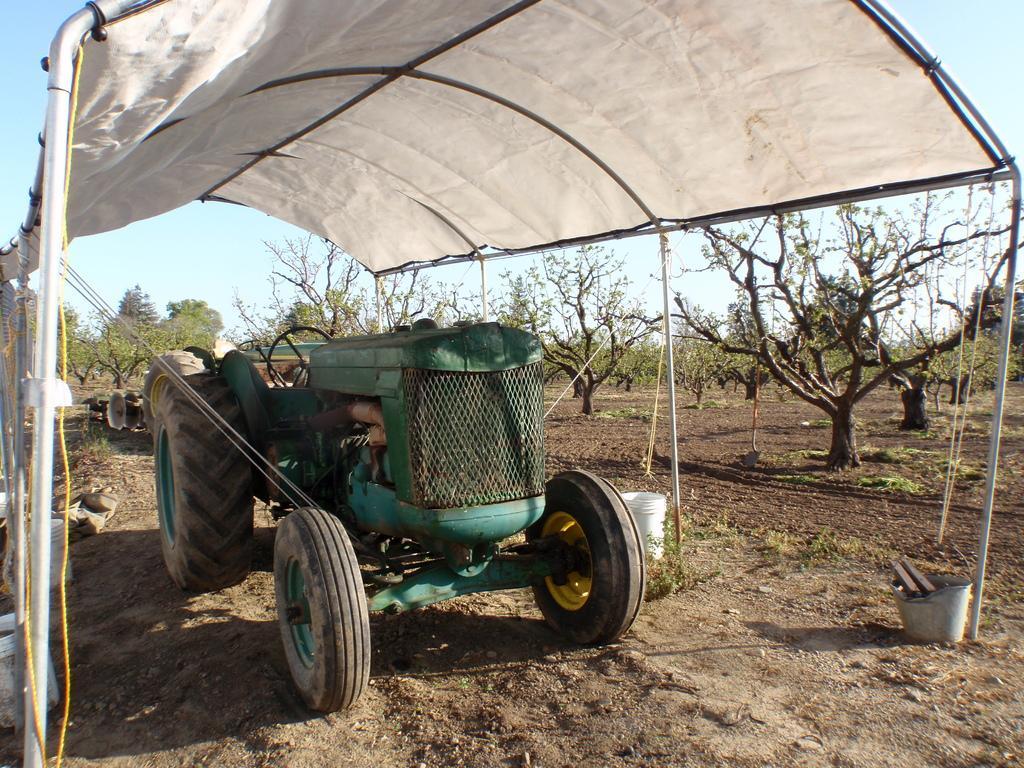How would you summarize this image in a sentence or two? In this image, this looks like a tractor. I think this is a shelter. These are the trees with branches and leaves. I think these are the buckets. 